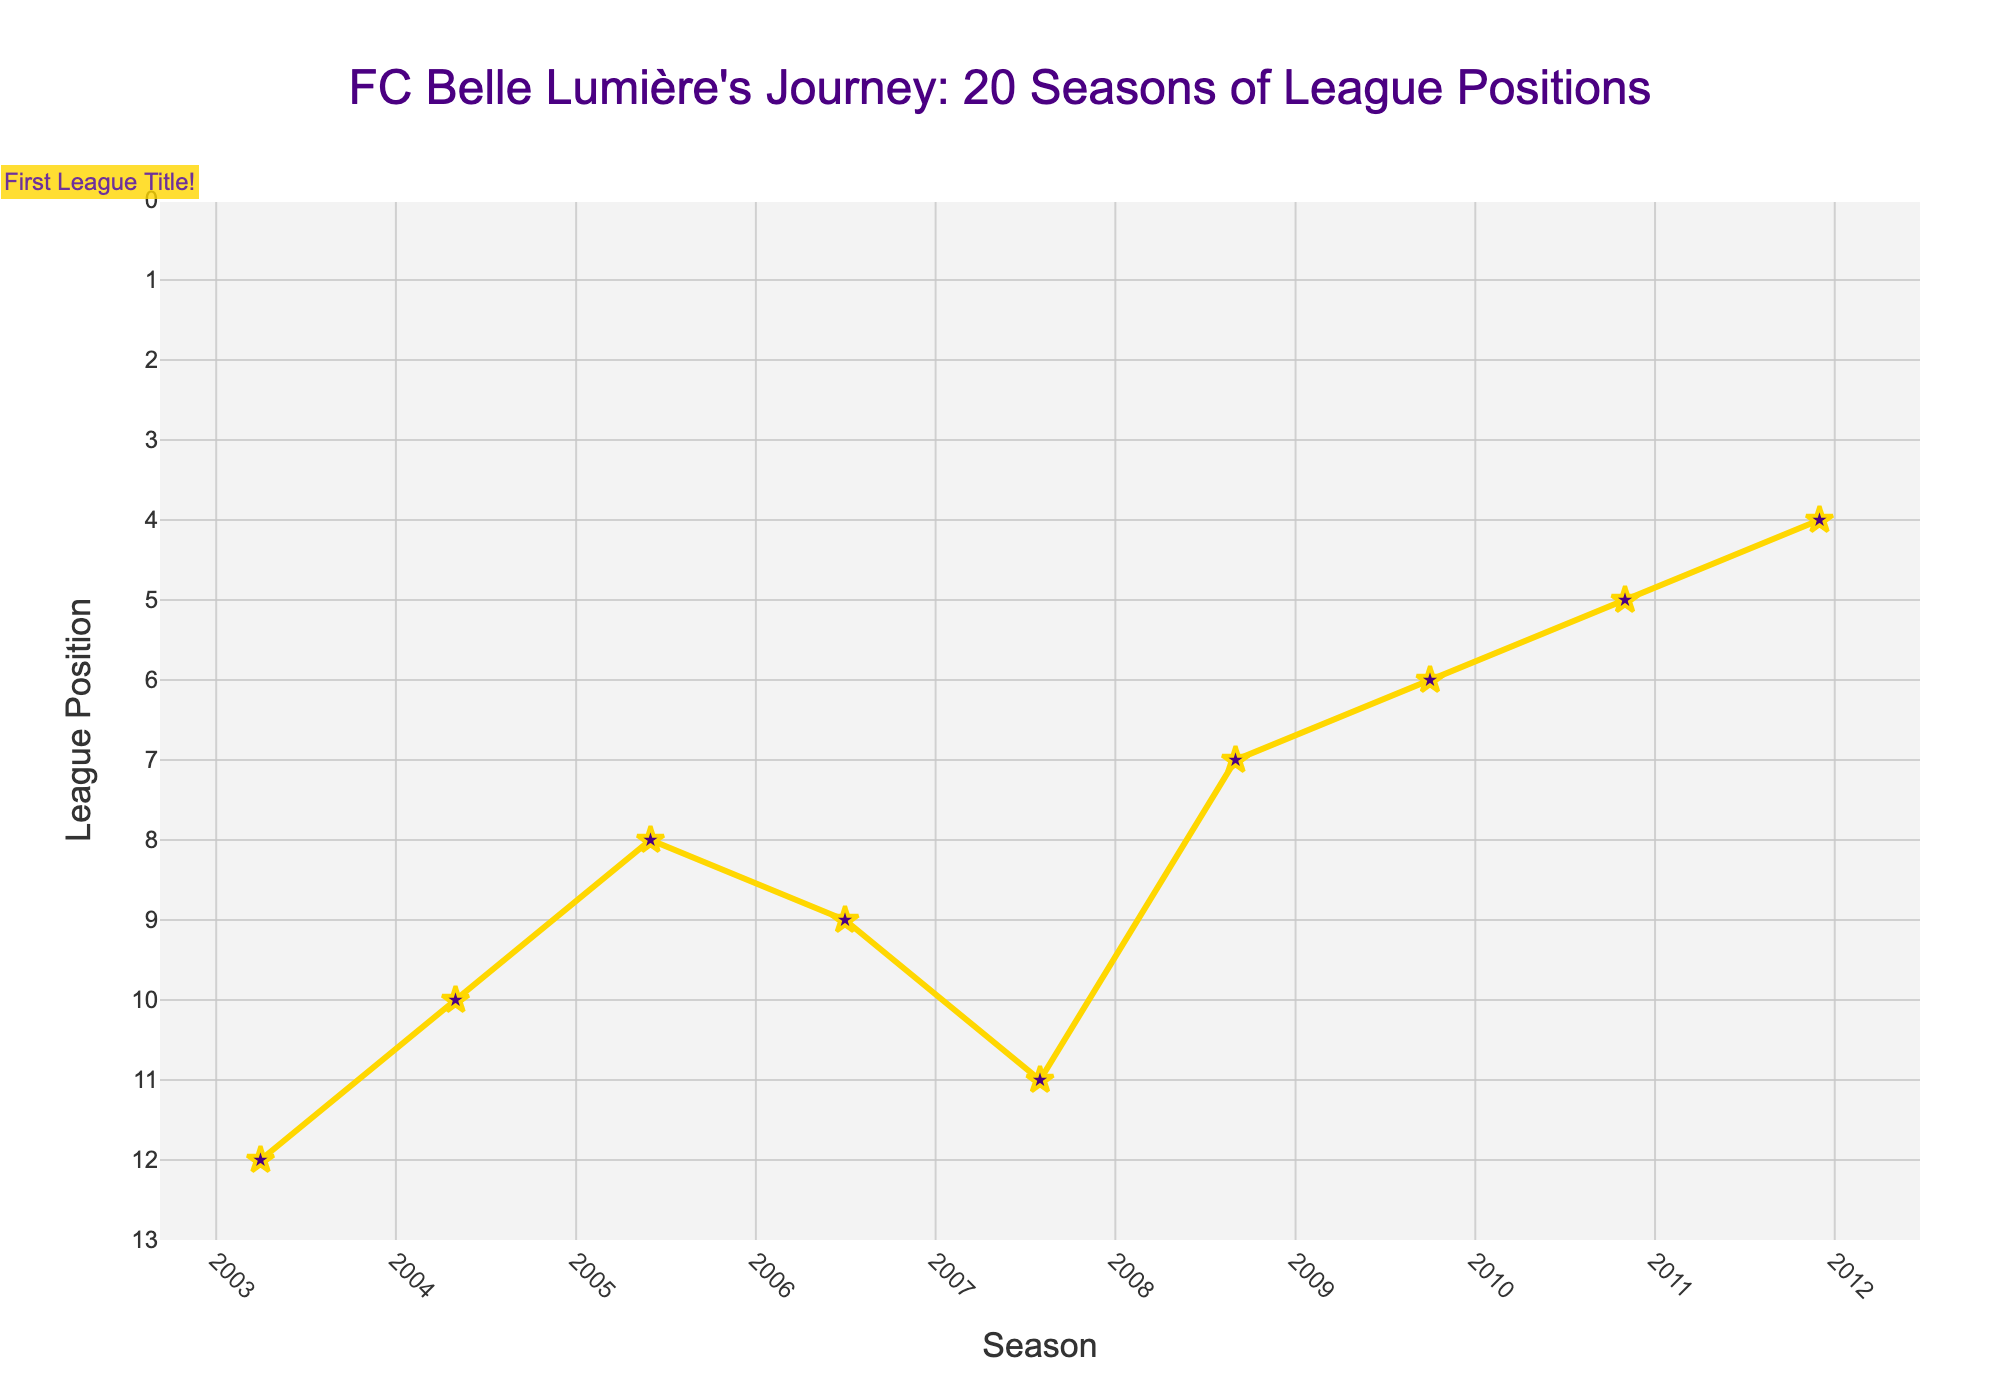Which season did FC Belle Lumière first win the league title? The annotation on the plot highlights the 2014-15 season with a label "First League Title!".
Answer: 2014-15 How many times did FC Belle Lumière finish first in the league? By counting the number of times the league position is at 1 on the plot, FC Belle Lumière finished first in the league during the 2014-15, 2015-16, and 2021-22 seasons.
Answer: 3 What was the league position of FC Belle Lumière in the 2008-09 season? By looking at the plot, in the 2008-09 season, the league position is marked at 7.
Answer: 7 In which seasons did FC Belle Lumière finish in the top 3 positions? Checking the plot for positions 1, 2, and 3, FC Belle Lumière finished in the top 3 in the following seasons: 2012-13, 2013-14, 2014-15, 2015-16, 2016-17, 2017-18, 2019-20, 2020-21, and 2022-23.
Answer: 9 seasons Compare FC Belle Lumière's league position between the 2005-06 and 2006-07 seasons. Which season had a better position? In the plot, the league position for 2005-06 is 8 and for 2006-07 is 9. Since a lower numerical position is better, 2005-06 had a better position.
Answer: 2005-06 What is the general trend in FC Belle Lumière's league positions from the 2003-04 season to the 2022-23 season? The plot shows an overall improvement with fluctuations, starting from 12th in 2003-04, reaching 1st by 2014-15, and maintaining mostly top 3 positions towards the end.
Answer: Improvement What is the range of FC Belle Lumière's league positions over the past 20 seasons? By examining the plot, the highest position (numerically smallest) is 1st, and the lowest (numerically largest) is 12th. Thus, the range is from 1 to 12.
Answer: 1 to 12 How many consecutive seasons did FC Belle Lumière maintain the first position? Referring to the plot, the team maintained the 1st position consecutively during the 2014-15 and 2015-16 seasons, so for 2 seasons.
Answer: 2 seasons How did FC Belle Lumière's league position change from the 2012-13 season to the 2013-14 season? The plot shows the league position changed from 3rd in the 2012-13 season to 2nd in the 2013-14 season, indicating an improvement.
Answer: Improved 